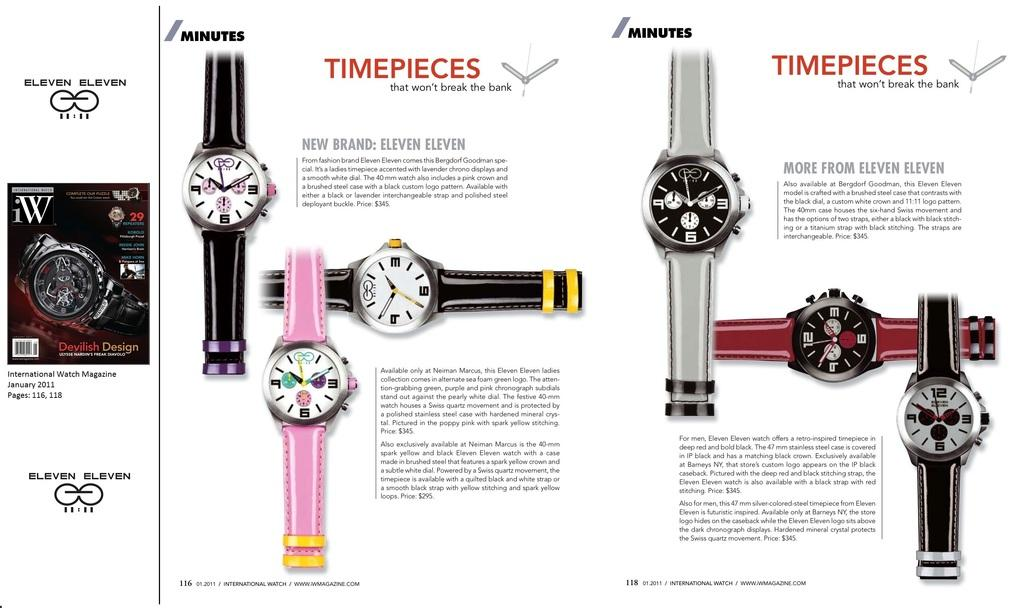<image>
Summarize the visual content of the image. an ad for Eleven Eleven Time pieces show many colorful watches 